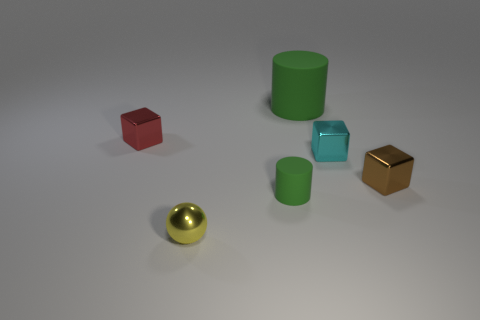Add 1 tiny metallic things. How many objects exist? 7 Subtract all balls. How many objects are left? 5 Add 6 small green cylinders. How many small green cylinders exist? 7 Subtract 0 yellow blocks. How many objects are left? 6 Subtract all cyan metal cylinders. Subtract all yellow objects. How many objects are left? 5 Add 2 big matte cylinders. How many big matte cylinders are left? 3 